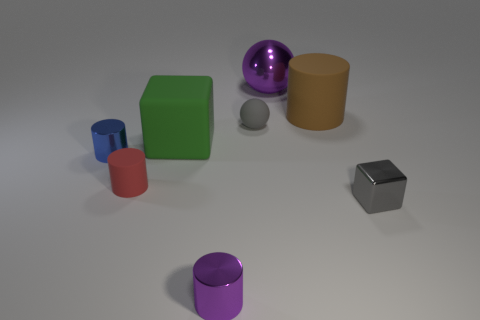What is the color of the block that is the same size as the purple shiny cylinder?
Make the answer very short. Gray. How many things are either red things or tiny purple shiny cylinders?
Ensure brevity in your answer.  2. There is a gray ball that is on the right side of the large thing that is left of the purple object that is behind the tiny purple shiny thing; what size is it?
Make the answer very short. Small. What number of small cylinders have the same color as the big sphere?
Make the answer very short. 1. How many tiny yellow balls are made of the same material as the tiny red object?
Your response must be concise. 0. How many objects are either big rubber blocks or big objects behind the brown matte object?
Ensure brevity in your answer.  2. There is a sphere that is behind the tiny matte thing that is to the right of the block left of the gray sphere; what color is it?
Ensure brevity in your answer.  Purple. How big is the purple thing that is behind the tiny shiny block?
Provide a succinct answer. Large. How many big things are either green blocks or purple balls?
Make the answer very short. 2. What is the color of the small metal thing that is both to the right of the big green rubber object and left of the purple ball?
Your answer should be very brief. Purple. 